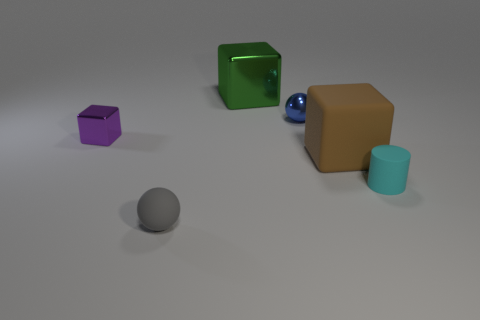How many blue blocks are the same size as the gray rubber object?
Provide a succinct answer. 0. What material is the tiny blue ball?
Your answer should be very brief. Metal. Is the number of big yellow matte things greater than the number of tiny gray balls?
Provide a succinct answer. No. Is the brown rubber thing the same shape as the blue shiny object?
Provide a short and direct response. No. Is there anything else that is the same shape as the large green thing?
Give a very brief answer. Yes. There is a tiny metal thing on the right side of the purple metallic block; does it have the same color as the shiny block to the right of the gray rubber ball?
Provide a succinct answer. No. Are there fewer small blocks that are to the right of the purple shiny cube than big cubes left of the brown thing?
Your answer should be compact. Yes. There is a rubber object behind the small cylinder; what is its shape?
Offer a very short reply. Cube. How many other things are the same material as the tiny blue sphere?
Keep it short and to the point. 2. Is the shape of the big brown object the same as the large thing that is behind the tiny blue object?
Make the answer very short. Yes. 